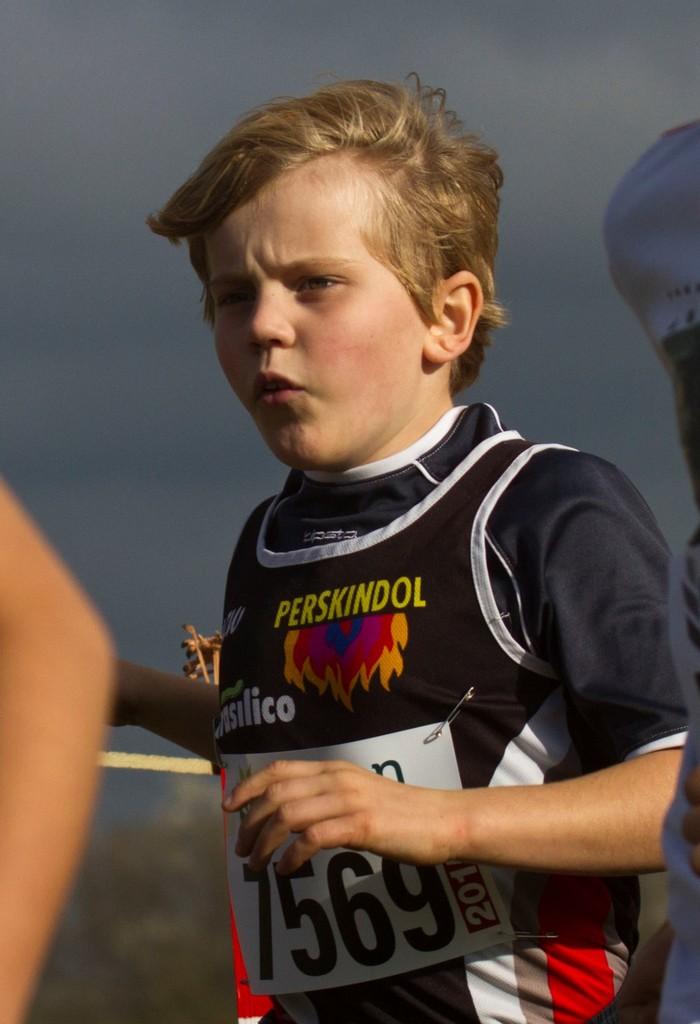What is this boy's race number?
Keep it short and to the point. 7569. 